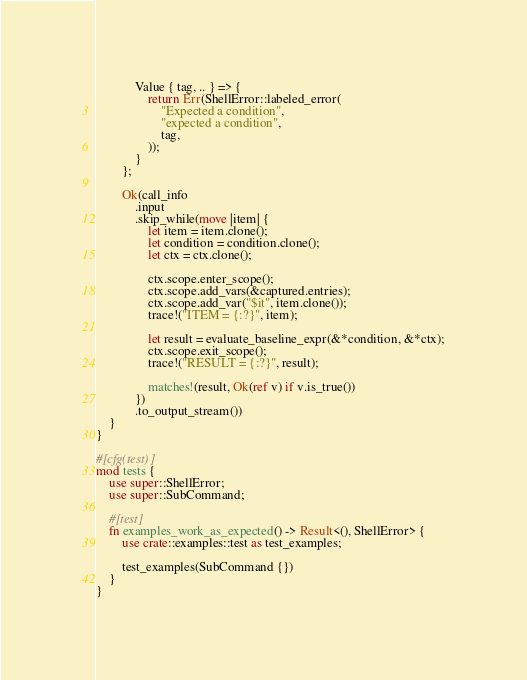<code> <loc_0><loc_0><loc_500><loc_500><_Rust_>            Value { tag, .. } => {
                return Err(ShellError::labeled_error(
                    "Expected a condition",
                    "expected a condition",
                    tag,
                ));
            }
        };

        Ok(call_info
            .input
            .skip_while(move |item| {
                let item = item.clone();
                let condition = condition.clone();
                let ctx = ctx.clone();

                ctx.scope.enter_scope();
                ctx.scope.add_vars(&captured.entries);
                ctx.scope.add_var("$it", item.clone());
                trace!("ITEM = {:?}", item);

                let result = evaluate_baseline_expr(&*condition, &*ctx);
                ctx.scope.exit_scope();
                trace!("RESULT = {:?}", result);

                matches!(result, Ok(ref v) if v.is_true())
            })
            .to_output_stream())
    }
}

#[cfg(test)]
mod tests {
    use super::ShellError;
    use super::SubCommand;

    #[test]
    fn examples_work_as_expected() -> Result<(), ShellError> {
        use crate::examples::test as test_examples;

        test_examples(SubCommand {})
    }
}
</code> 